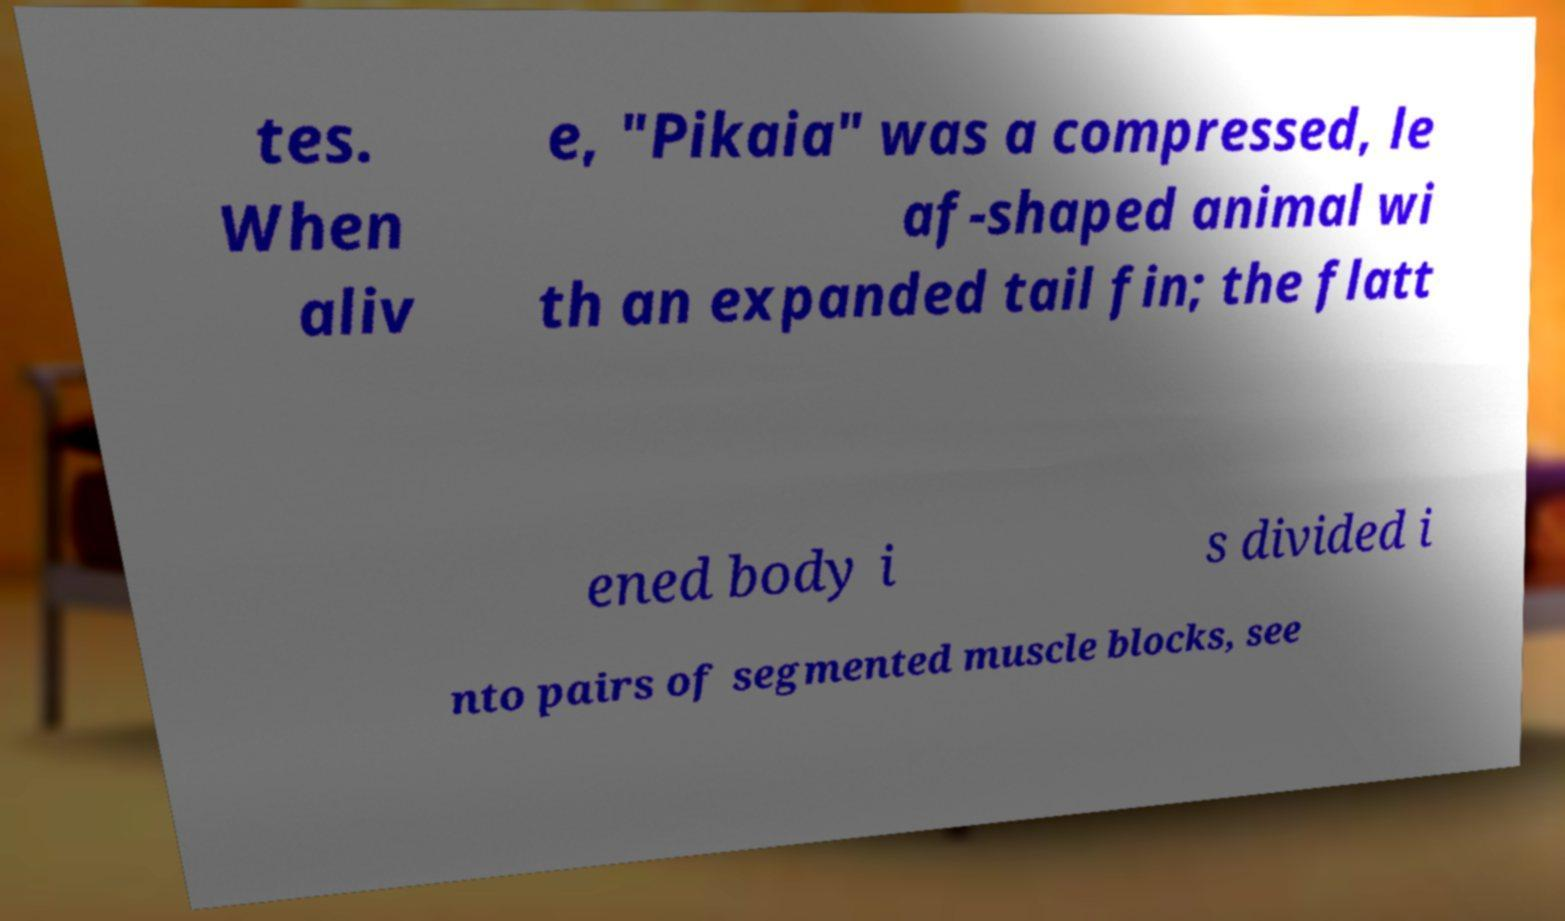I need the written content from this picture converted into text. Can you do that? tes. When aliv e, "Pikaia" was a compressed, le af-shaped animal wi th an expanded tail fin; the flatt ened body i s divided i nto pairs of segmented muscle blocks, see 